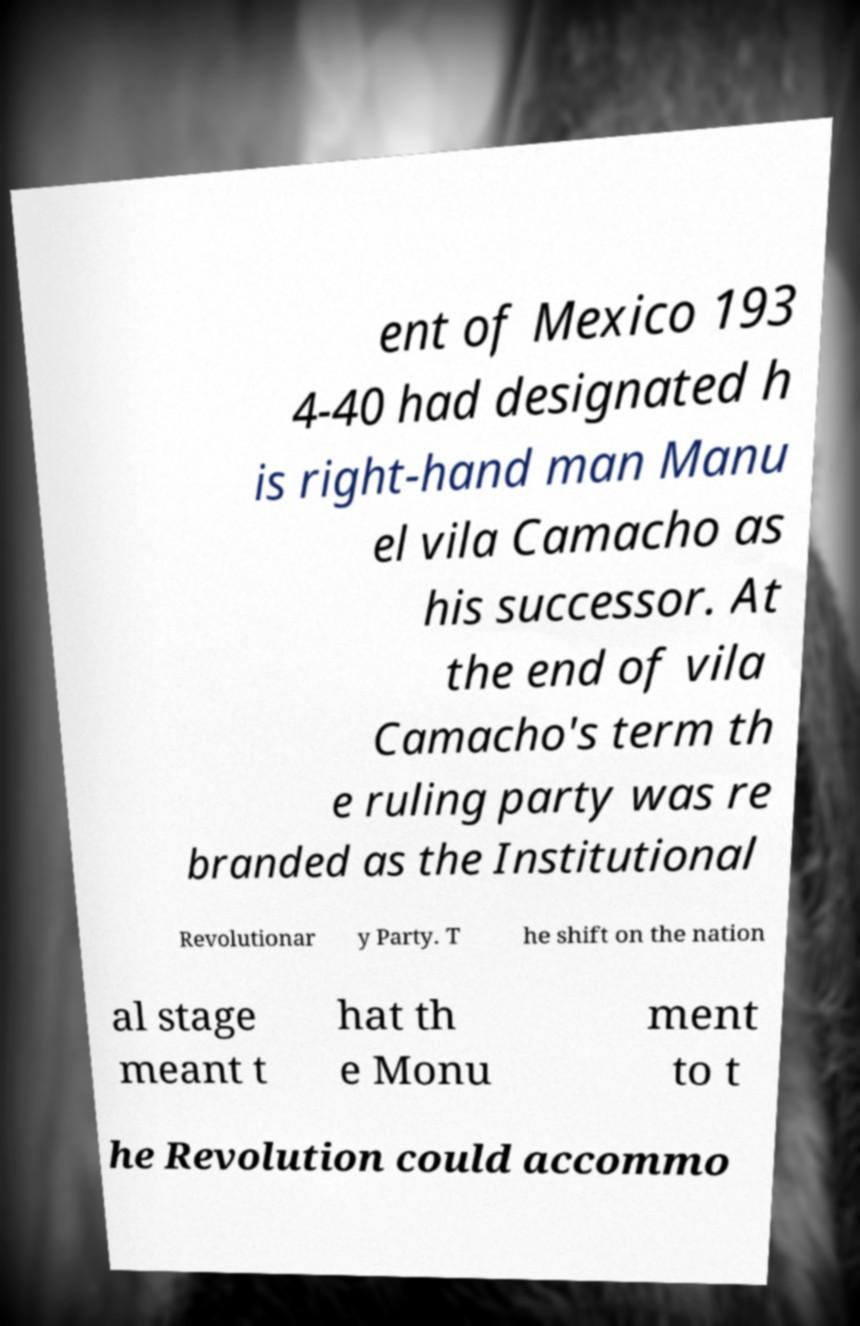What messages or text are displayed in this image? I need them in a readable, typed format. ent of Mexico 193 4-40 had designated h is right-hand man Manu el vila Camacho as his successor. At the end of vila Camacho's term th e ruling party was re branded as the Institutional Revolutionar y Party. T he shift on the nation al stage meant t hat th e Monu ment to t he Revolution could accommo 